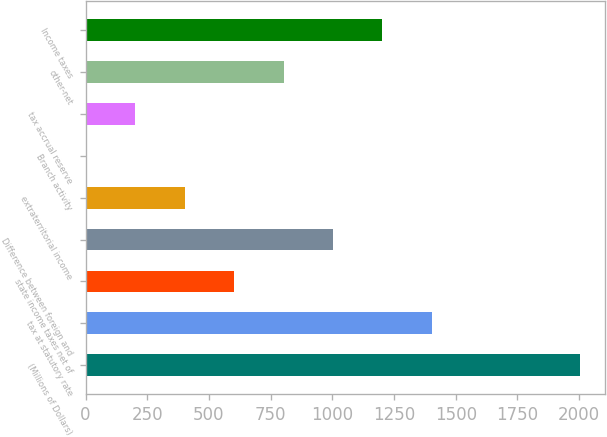Convert chart. <chart><loc_0><loc_0><loc_500><loc_500><bar_chart><fcel>(Millions of Dollars)<fcel>tax at statutory rate<fcel>state income taxes net of<fcel>Difference between foreign and<fcel>extraterritorial income<fcel>Branch activity<fcel>tax accrual reserve<fcel>other-net<fcel>Income taxes<nl><fcel>2005<fcel>1403.62<fcel>601.78<fcel>1002.7<fcel>401.32<fcel>0.4<fcel>200.86<fcel>802.24<fcel>1203.16<nl></chart> 